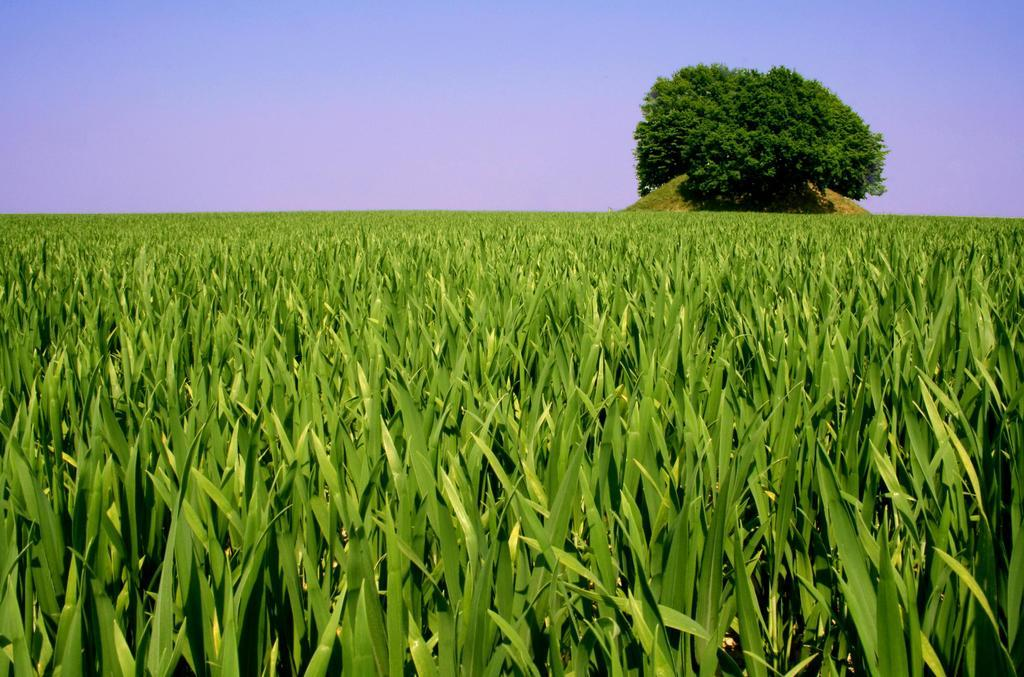What can be seen in the background of the image? The sky is visible in the background of the image, along with a tree. What is the main subject of the image? The image is mainly focused on a field. How would you describe the field in the image? The field is full of greenery. What type of hospital can be seen in the image? There is no hospital present in the image; it features a field with greenery and a background with a sky and a tree. 